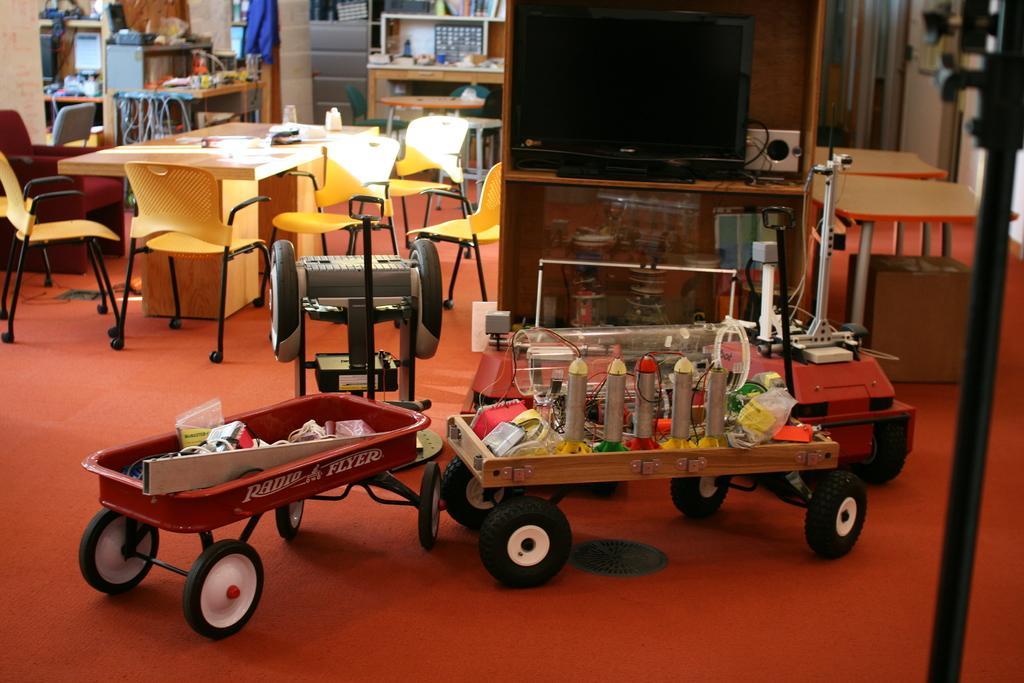How would you summarize this image in a sentence or two? This is the table with few objects placed on it. These are the empty chairs which are yellow in color. This is the television placed on the television stand. These are the wheel carts with objects and things placed on it. At background I can see few objects placed on the table. This is the floor which is red in color. This looks like a cardboard box. 